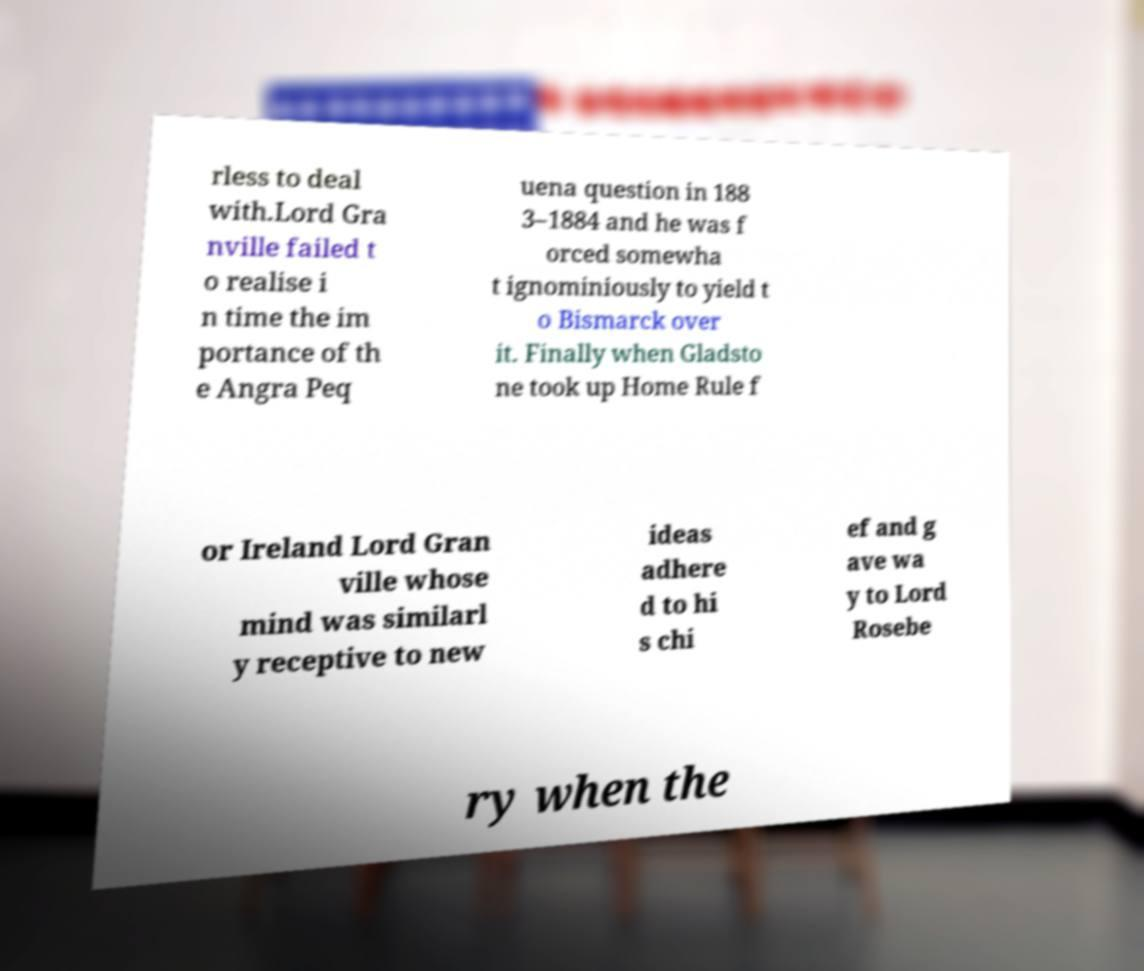Could you extract and type out the text from this image? rless to deal with.Lord Gra nville failed t o realise i n time the im portance of th e Angra Peq uena question in 188 3–1884 and he was f orced somewha t ignominiously to yield t o Bismarck over it. Finally when Gladsto ne took up Home Rule f or Ireland Lord Gran ville whose mind was similarl y receptive to new ideas adhere d to hi s chi ef and g ave wa y to Lord Rosebe ry when the 